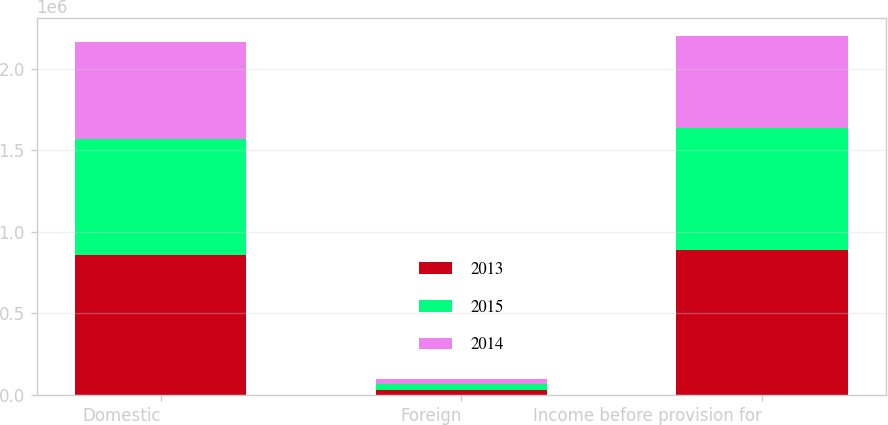Convert chart to OTSL. <chart><loc_0><loc_0><loc_500><loc_500><stacked_bar_chart><ecel><fcel>Domestic<fcel>Foreign<fcel>Income before provision for<nl><fcel>2013<fcel>859039<fcel>32509<fcel>891548<nl><fcel>2015<fcel>711917<fcel>33871<fcel>745788<nl><fcel>2014<fcel>596899<fcel>33005<fcel>563894<nl></chart> 